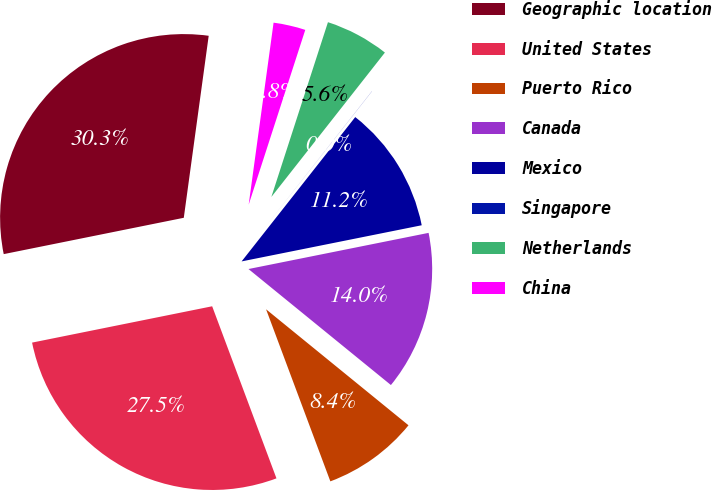<chart> <loc_0><loc_0><loc_500><loc_500><pie_chart><fcel>Geographic location<fcel>United States<fcel>Puerto Rico<fcel>Canada<fcel>Mexico<fcel>Singapore<fcel>Netherlands<fcel>China<nl><fcel>30.33%<fcel>27.52%<fcel>8.43%<fcel>14.03%<fcel>11.23%<fcel>0.01%<fcel>5.62%<fcel>2.82%<nl></chart> 